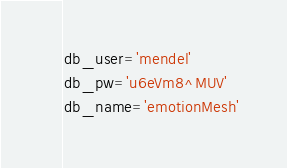Convert code to text. <code><loc_0><loc_0><loc_500><loc_500><_Python_>db_user='mendel'
db_pw='u6eVm8^MUV'
db_name='emotionMesh'</code> 